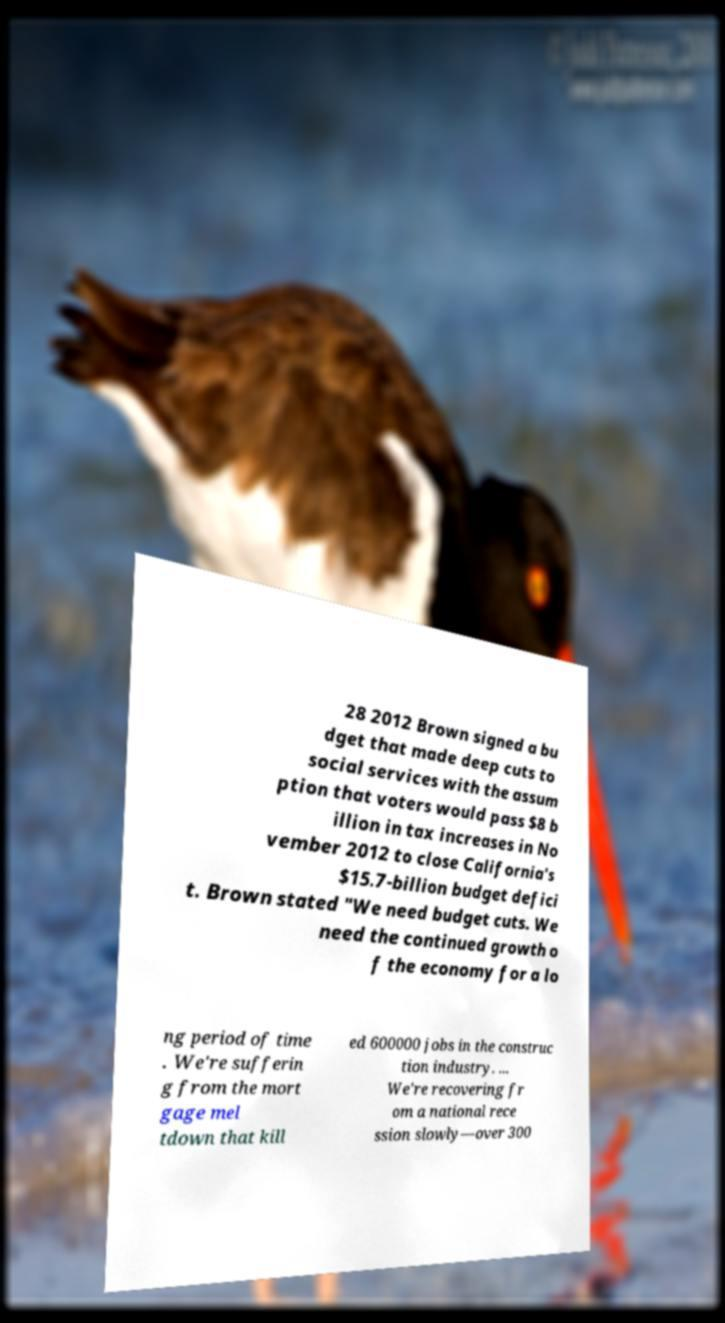What messages or text are displayed in this image? I need them in a readable, typed format. 28 2012 Brown signed a bu dget that made deep cuts to social services with the assum ption that voters would pass $8 b illion in tax increases in No vember 2012 to close California's $15.7-billion budget defici t. Brown stated "We need budget cuts. We need the continued growth o f the economy for a lo ng period of time . We're sufferin g from the mort gage mel tdown that kill ed 600000 jobs in the construc tion industry. ... We're recovering fr om a national rece ssion slowly—over 300 